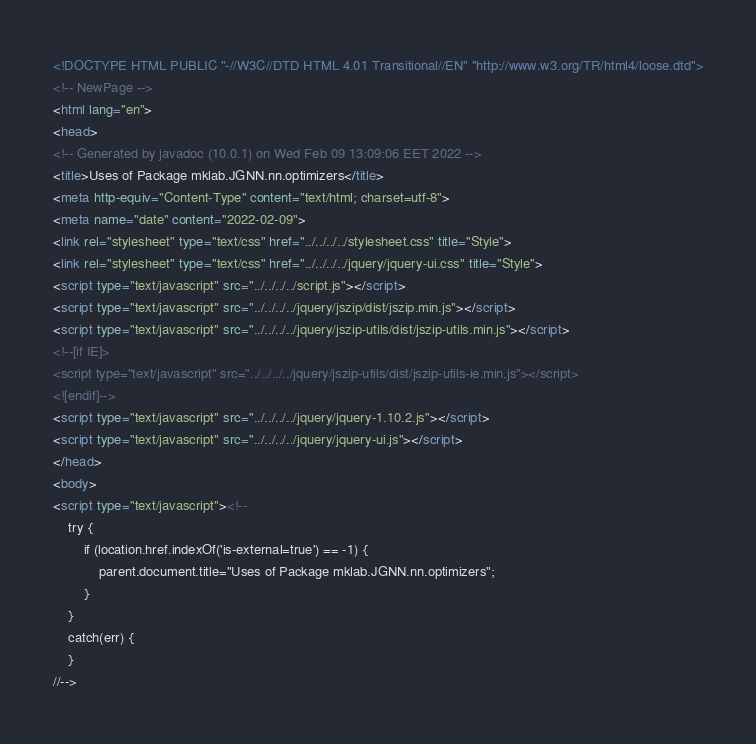<code> <loc_0><loc_0><loc_500><loc_500><_HTML_><!DOCTYPE HTML PUBLIC "-//W3C//DTD HTML 4.01 Transitional//EN" "http://www.w3.org/TR/html4/loose.dtd">
<!-- NewPage -->
<html lang="en">
<head>
<!-- Generated by javadoc (10.0.1) on Wed Feb 09 13:09:06 EET 2022 -->
<title>Uses of Package mklab.JGNN.nn.optimizers</title>
<meta http-equiv="Content-Type" content="text/html; charset=utf-8">
<meta name="date" content="2022-02-09">
<link rel="stylesheet" type="text/css" href="../../../../stylesheet.css" title="Style">
<link rel="stylesheet" type="text/css" href="../../../../jquery/jquery-ui.css" title="Style">
<script type="text/javascript" src="../../../../script.js"></script>
<script type="text/javascript" src="../../../../jquery/jszip/dist/jszip.min.js"></script>
<script type="text/javascript" src="../../../../jquery/jszip-utils/dist/jszip-utils.min.js"></script>
<!--[if IE]>
<script type="text/javascript" src="../../../../jquery/jszip-utils/dist/jszip-utils-ie.min.js"></script>
<![endif]-->
<script type="text/javascript" src="../../../../jquery/jquery-1.10.2.js"></script>
<script type="text/javascript" src="../../../../jquery/jquery-ui.js"></script>
</head>
<body>
<script type="text/javascript"><!--
    try {
        if (location.href.indexOf('is-external=true') == -1) {
            parent.document.title="Uses of Package mklab.JGNN.nn.optimizers";
        }
    }
    catch(err) {
    }
//--></code> 